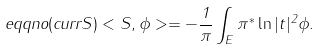Convert formula to latex. <formula><loc_0><loc_0><loc_500><loc_500>\ e q q n o ( c u r r S ) < S , \phi > = - \frac { 1 } { \pi } \int _ { E } \pi ^ { * } \ln | t | ^ { 2 } \phi .</formula> 